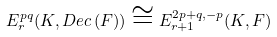Convert formula to latex. <formula><loc_0><loc_0><loc_500><loc_500>E _ { r } ^ { p q } ( K , D e c \, ( F ) ) \cong E _ { r + 1 } ^ { 2 p + q , - p } ( K , F )</formula> 